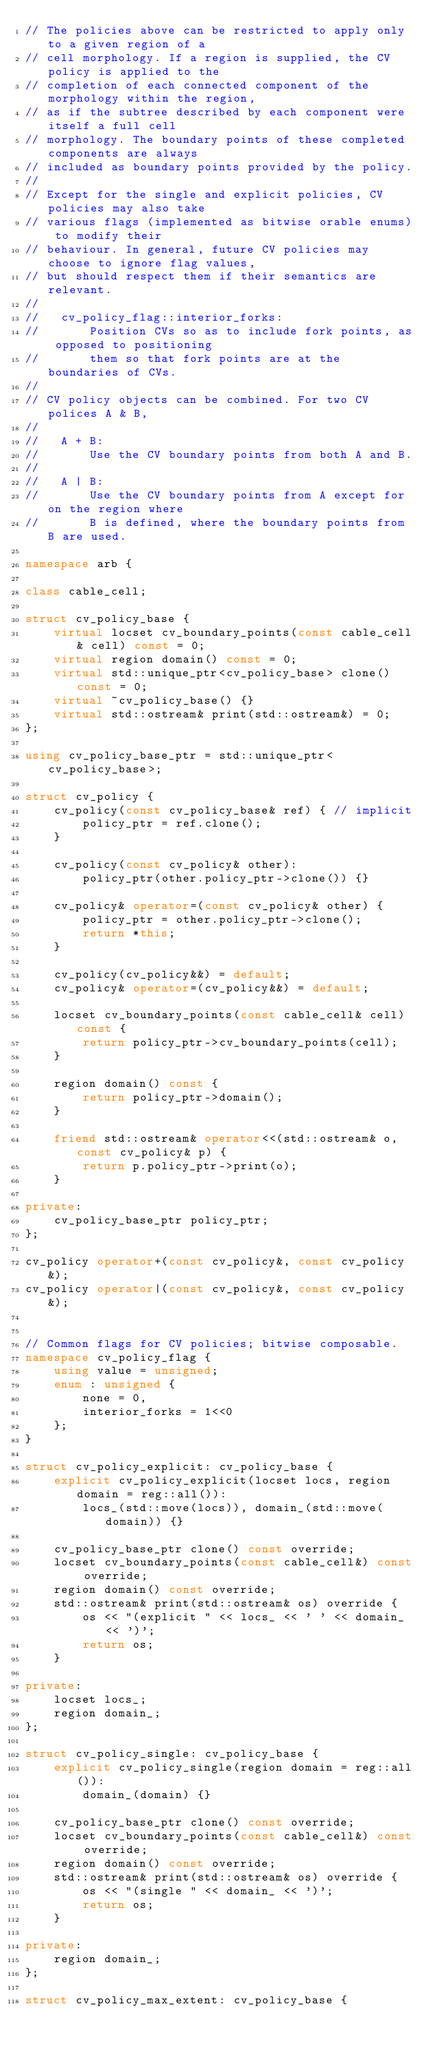<code> <loc_0><loc_0><loc_500><loc_500><_C++_>// The policies above can be restricted to apply only to a given region of a
// cell morphology. If a region is supplied, the CV policy is applied to the
// completion of each connected component of the morphology within the region,
// as if the subtree described by each component were itself a full cell
// morphology. The boundary points of these completed components are always
// included as boundary points provided by the policy.
//
// Except for the single and explicit policies, CV policies may also take
// various flags (implemented as bitwise orable enums) to modify their
// behaviour. In general, future CV policies may choose to ignore flag values,
// but should respect them if their semantics are relevant.
//
//   cv_policy_flag::interior_forks:
//       Position CVs so as to include fork points, as opposed to positioning
//       them so that fork points are at the boundaries of CVs.
//
// CV policy objects can be combined. For two CV polices A & B,
//
//   A + B:
//       Use the CV boundary points from both A and B.
//
//   A | B:
//       Use the CV boundary points from A except for on the region where
//       B is defined, where the boundary points from B are used.

namespace arb {

class cable_cell;

struct cv_policy_base {
    virtual locset cv_boundary_points(const cable_cell& cell) const = 0;
    virtual region domain() const = 0;
    virtual std::unique_ptr<cv_policy_base> clone() const = 0;
    virtual ~cv_policy_base() {}
    virtual std::ostream& print(std::ostream&) = 0;
};

using cv_policy_base_ptr = std::unique_ptr<cv_policy_base>;

struct cv_policy {
    cv_policy(const cv_policy_base& ref) { // implicit
        policy_ptr = ref.clone();
    }

    cv_policy(const cv_policy& other):
        policy_ptr(other.policy_ptr->clone()) {}

    cv_policy& operator=(const cv_policy& other) {
        policy_ptr = other.policy_ptr->clone();
        return *this;
    }

    cv_policy(cv_policy&&) = default;
    cv_policy& operator=(cv_policy&&) = default;

    locset cv_boundary_points(const cable_cell& cell) const {
        return policy_ptr->cv_boundary_points(cell);
    }

    region domain() const {
        return policy_ptr->domain();
    }

    friend std::ostream& operator<<(std::ostream& o, const cv_policy& p) {
        return p.policy_ptr->print(o);
    }

private:
    cv_policy_base_ptr policy_ptr;
};

cv_policy operator+(const cv_policy&, const cv_policy&);
cv_policy operator|(const cv_policy&, const cv_policy&);


// Common flags for CV policies; bitwise composable.
namespace cv_policy_flag {
    using value = unsigned;
    enum : unsigned {
        none = 0,
        interior_forks = 1<<0
    };
}

struct cv_policy_explicit: cv_policy_base {
    explicit cv_policy_explicit(locset locs, region domain = reg::all()):
        locs_(std::move(locs)), domain_(std::move(domain)) {}

    cv_policy_base_ptr clone() const override;
    locset cv_boundary_points(const cable_cell&) const override;
    region domain() const override;
    std::ostream& print(std::ostream& os) override {
        os << "(explicit " << locs_ << ' ' << domain_ << ')';
        return os;
    }

private:
    locset locs_;
    region domain_;
};

struct cv_policy_single: cv_policy_base {
    explicit cv_policy_single(region domain = reg::all()):
        domain_(domain) {}

    cv_policy_base_ptr clone() const override;
    locset cv_boundary_points(const cable_cell&) const override;
    region domain() const override;
    std::ostream& print(std::ostream& os) override {
        os << "(single " << domain_ << ')';
        return os;
    }

private:
    region domain_;
};

struct cv_policy_max_extent: cv_policy_base {</code> 